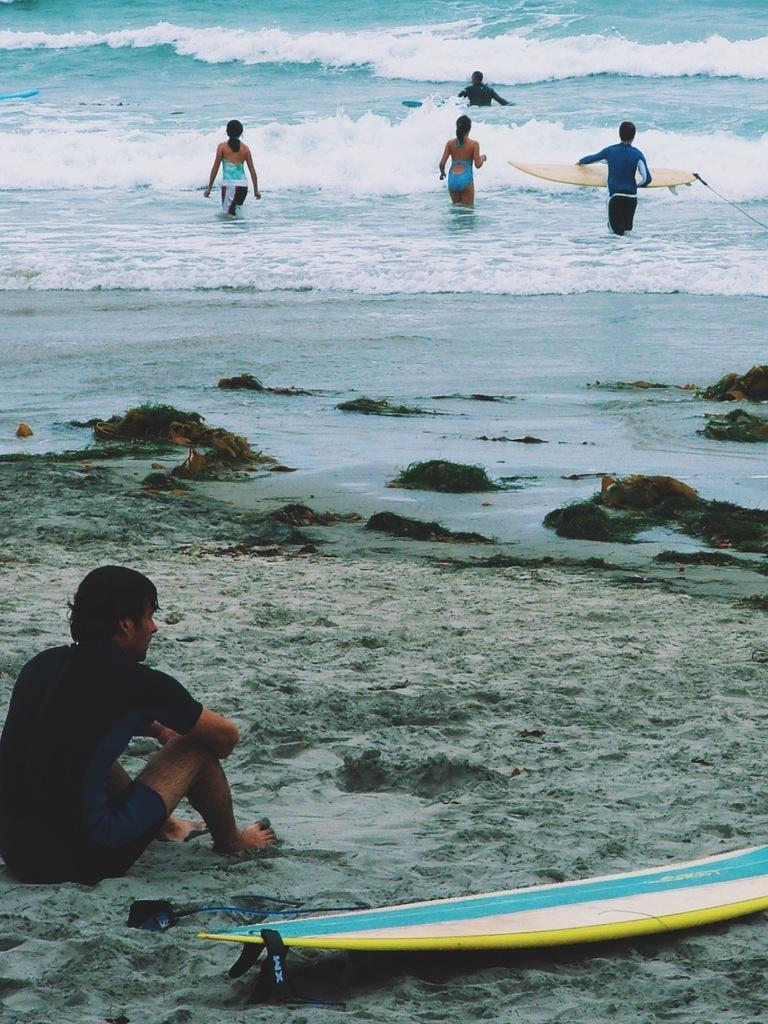How would you summarize this image in a sentence or two? In this image there is a person sitting on the land and there is a surfboard at the right side of the person. There are four persons on the water and one of the person is holding the surf board. 